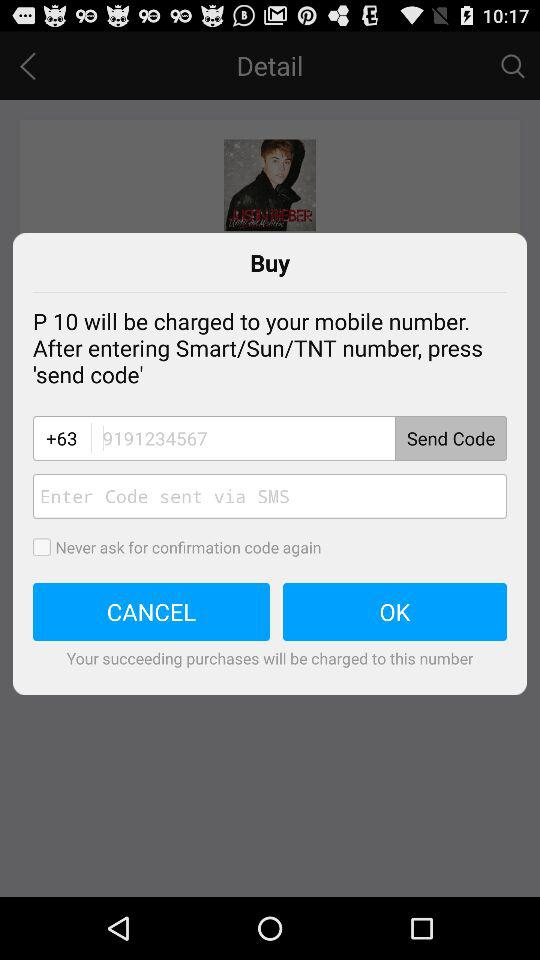What will be charged to the user's mobile number? To the user's mobile number, "P 10" will be charged. 